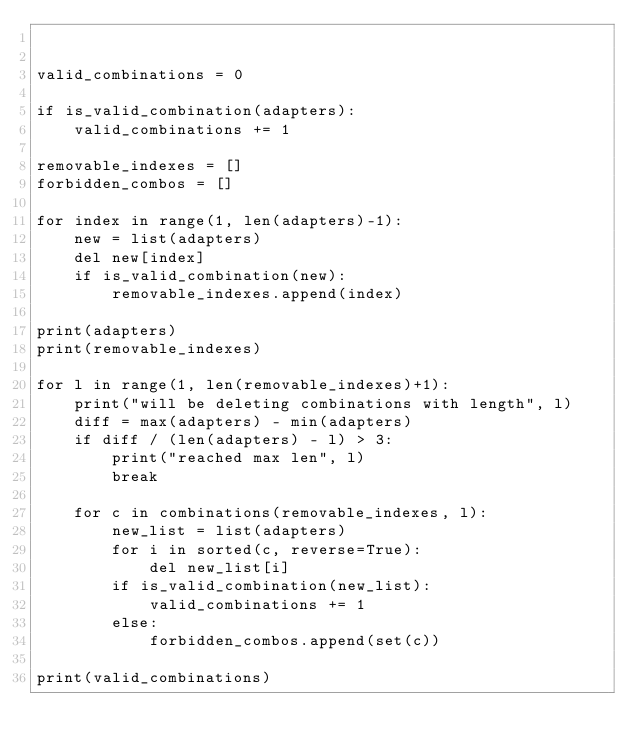<code> <loc_0><loc_0><loc_500><loc_500><_Python_>

valid_combinations = 0

if is_valid_combination(adapters):
    valid_combinations += 1

removable_indexes = []
forbidden_combos = []

for index in range(1, len(adapters)-1):
    new = list(adapters)
    del new[index]
    if is_valid_combination(new):
        removable_indexes.append(index)

print(adapters)
print(removable_indexes)

for l in range(1, len(removable_indexes)+1):
    print("will be deleting combinations with length", l)
    diff = max(adapters) - min(adapters)
    if diff / (len(adapters) - l) > 3:
        print("reached max len", l)
        break

    for c in combinations(removable_indexes, l):
        new_list = list(adapters)
        for i in sorted(c, reverse=True):
            del new_list[i]
        if is_valid_combination(new_list):
            valid_combinations += 1
        else:
            forbidden_combos.append(set(c))

print(valid_combinations)
</code> 